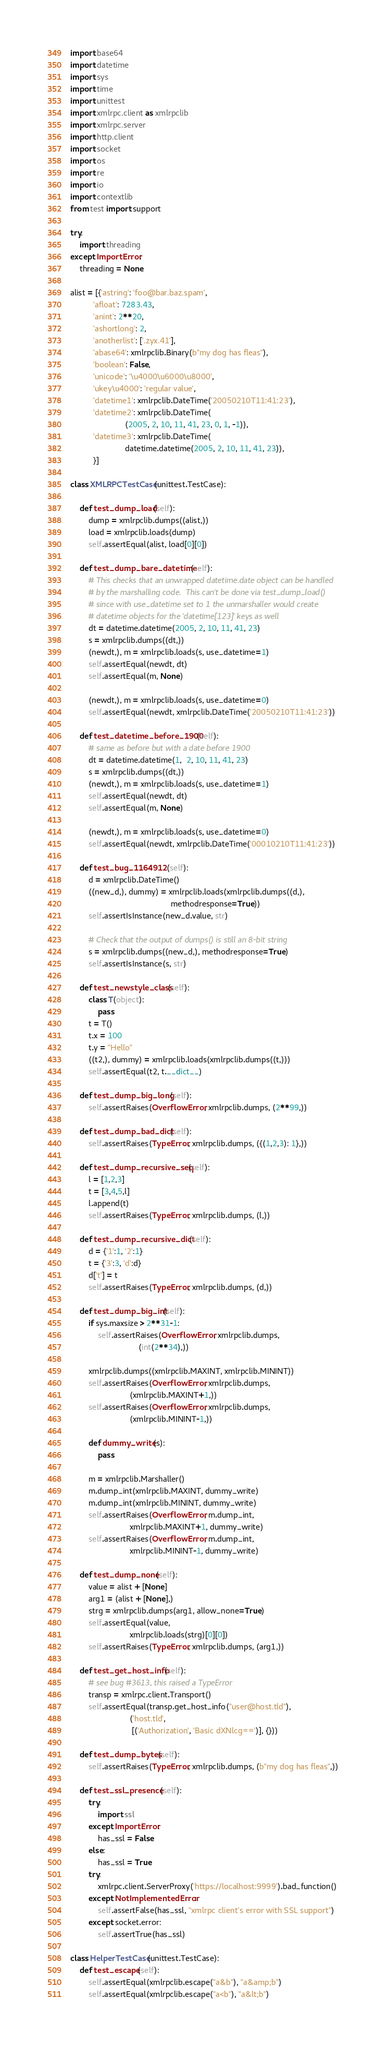Convert code to text. <code><loc_0><loc_0><loc_500><loc_500><_Python_>import base64
import datetime
import sys
import time
import unittest
import xmlrpc.client as xmlrpclib
import xmlrpc.server
import http.client
import socket
import os
import re
import io
import contextlib
from test import support

try:
    import threading
except ImportError:
    threading = None

alist = [{'astring': 'foo@bar.baz.spam',
          'afloat': 7283.43,
          'anint': 2**20,
          'ashortlong': 2,
          'anotherlist': ['.zyx.41'],
          'abase64': xmlrpclib.Binary(b"my dog has fleas"),
          'boolean': False,
          'unicode': '\u4000\u6000\u8000',
          'ukey\u4000': 'regular value',
          'datetime1': xmlrpclib.DateTime('20050210T11:41:23'),
          'datetime2': xmlrpclib.DateTime(
                        (2005, 2, 10, 11, 41, 23, 0, 1, -1)),
          'datetime3': xmlrpclib.DateTime(
                        datetime.datetime(2005, 2, 10, 11, 41, 23)),
          }]

class XMLRPCTestCase(unittest.TestCase):

    def test_dump_load(self):
        dump = xmlrpclib.dumps((alist,))
        load = xmlrpclib.loads(dump)
        self.assertEqual(alist, load[0][0])

    def test_dump_bare_datetime(self):
        # This checks that an unwrapped datetime.date object can be handled
        # by the marshalling code.  This can't be done via test_dump_load()
        # since with use_datetime set to 1 the unmarshaller would create
        # datetime objects for the 'datetime[123]' keys as well
        dt = datetime.datetime(2005, 2, 10, 11, 41, 23)
        s = xmlrpclib.dumps((dt,))
        (newdt,), m = xmlrpclib.loads(s, use_datetime=1)
        self.assertEqual(newdt, dt)
        self.assertEqual(m, None)

        (newdt,), m = xmlrpclib.loads(s, use_datetime=0)
        self.assertEqual(newdt, xmlrpclib.DateTime('20050210T11:41:23'))

    def test_datetime_before_1900(self):
        # same as before but with a date before 1900
        dt = datetime.datetime(1,  2, 10, 11, 41, 23)
        s = xmlrpclib.dumps((dt,))
        (newdt,), m = xmlrpclib.loads(s, use_datetime=1)
        self.assertEqual(newdt, dt)
        self.assertEqual(m, None)

        (newdt,), m = xmlrpclib.loads(s, use_datetime=0)
        self.assertEqual(newdt, xmlrpclib.DateTime('00010210T11:41:23'))

    def test_bug_1164912 (self):
        d = xmlrpclib.DateTime()
        ((new_d,), dummy) = xmlrpclib.loads(xmlrpclib.dumps((d,),
                                            methodresponse=True))
        self.assertIsInstance(new_d.value, str)

        # Check that the output of dumps() is still an 8-bit string
        s = xmlrpclib.dumps((new_d,), methodresponse=True)
        self.assertIsInstance(s, str)

    def test_newstyle_class(self):
        class T(object):
            pass
        t = T()
        t.x = 100
        t.y = "Hello"
        ((t2,), dummy) = xmlrpclib.loads(xmlrpclib.dumps((t,)))
        self.assertEqual(t2, t.__dict__)

    def test_dump_big_long(self):
        self.assertRaises(OverflowError, xmlrpclib.dumps, (2**99,))

    def test_dump_bad_dict(self):
        self.assertRaises(TypeError, xmlrpclib.dumps, ({(1,2,3): 1},))

    def test_dump_recursive_seq(self):
        l = [1,2,3]
        t = [3,4,5,l]
        l.append(t)
        self.assertRaises(TypeError, xmlrpclib.dumps, (l,))

    def test_dump_recursive_dict(self):
        d = {'1':1, '2':1}
        t = {'3':3, 'd':d}
        d['t'] = t
        self.assertRaises(TypeError, xmlrpclib.dumps, (d,))

    def test_dump_big_int(self):
        if sys.maxsize > 2**31-1:
            self.assertRaises(OverflowError, xmlrpclib.dumps,
                              (int(2**34),))

        xmlrpclib.dumps((xmlrpclib.MAXINT, xmlrpclib.MININT))
        self.assertRaises(OverflowError, xmlrpclib.dumps,
                          (xmlrpclib.MAXINT+1,))
        self.assertRaises(OverflowError, xmlrpclib.dumps,
                          (xmlrpclib.MININT-1,))

        def dummy_write(s):
            pass

        m = xmlrpclib.Marshaller()
        m.dump_int(xmlrpclib.MAXINT, dummy_write)
        m.dump_int(xmlrpclib.MININT, dummy_write)
        self.assertRaises(OverflowError, m.dump_int,
                          xmlrpclib.MAXINT+1, dummy_write)
        self.assertRaises(OverflowError, m.dump_int,
                          xmlrpclib.MININT-1, dummy_write)

    def test_dump_none(self):
        value = alist + [None]
        arg1 = (alist + [None],)
        strg = xmlrpclib.dumps(arg1, allow_none=True)
        self.assertEqual(value,
                          xmlrpclib.loads(strg)[0][0])
        self.assertRaises(TypeError, xmlrpclib.dumps, (arg1,))

    def test_get_host_info(self):
        # see bug #3613, this raised a TypeError
        transp = xmlrpc.client.Transport()
        self.assertEqual(transp.get_host_info("user@host.tld"),
                          ('host.tld',
                           [('Authorization', 'Basic dXNlcg==')], {}))

    def test_dump_bytes(self):
        self.assertRaises(TypeError, xmlrpclib.dumps, (b"my dog has fleas",))

    def test_ssl_presence(self):
        try:
            import ssl
        except ImportError:
            has_ssl = False
        else:
            has_ssl = True
        try:
            xmlrpc.client.ServerProxy('https://localhost:9999').bad_function()
        except NotImplementedError:
            self.assertFalse(has_ssl, "xmlrpc client's error with SSL support")
        except socket.error:
            self.assertTrue(has_ssl)

class HelperTestCase(unittest.TestCase):
    def test_escape(self):
        self.assertEqual(xmlrpclib.escape("a&b"), "a&amp;b")
        self.assertEqual(xmlrpclib.escape("a<b"), "a&lt;b")</code> 